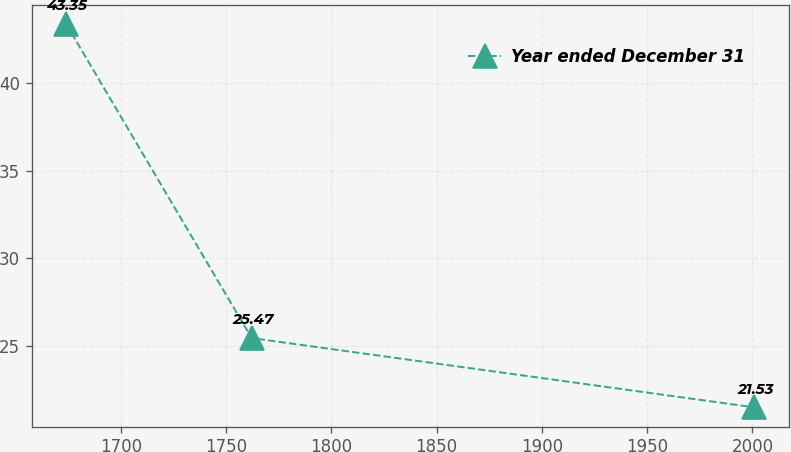Convert chart to OTSL. <chart><loc_0><loc_0><loc_500><loc_500><line_chart><ecel><fcel>Year ended December 31<nl><fcel>1673.96<fcel>43.35<nl><fcel>1762.14<fcel>25.47<nl><fcel>2000.86<fcel>21.53<nl></chart> 